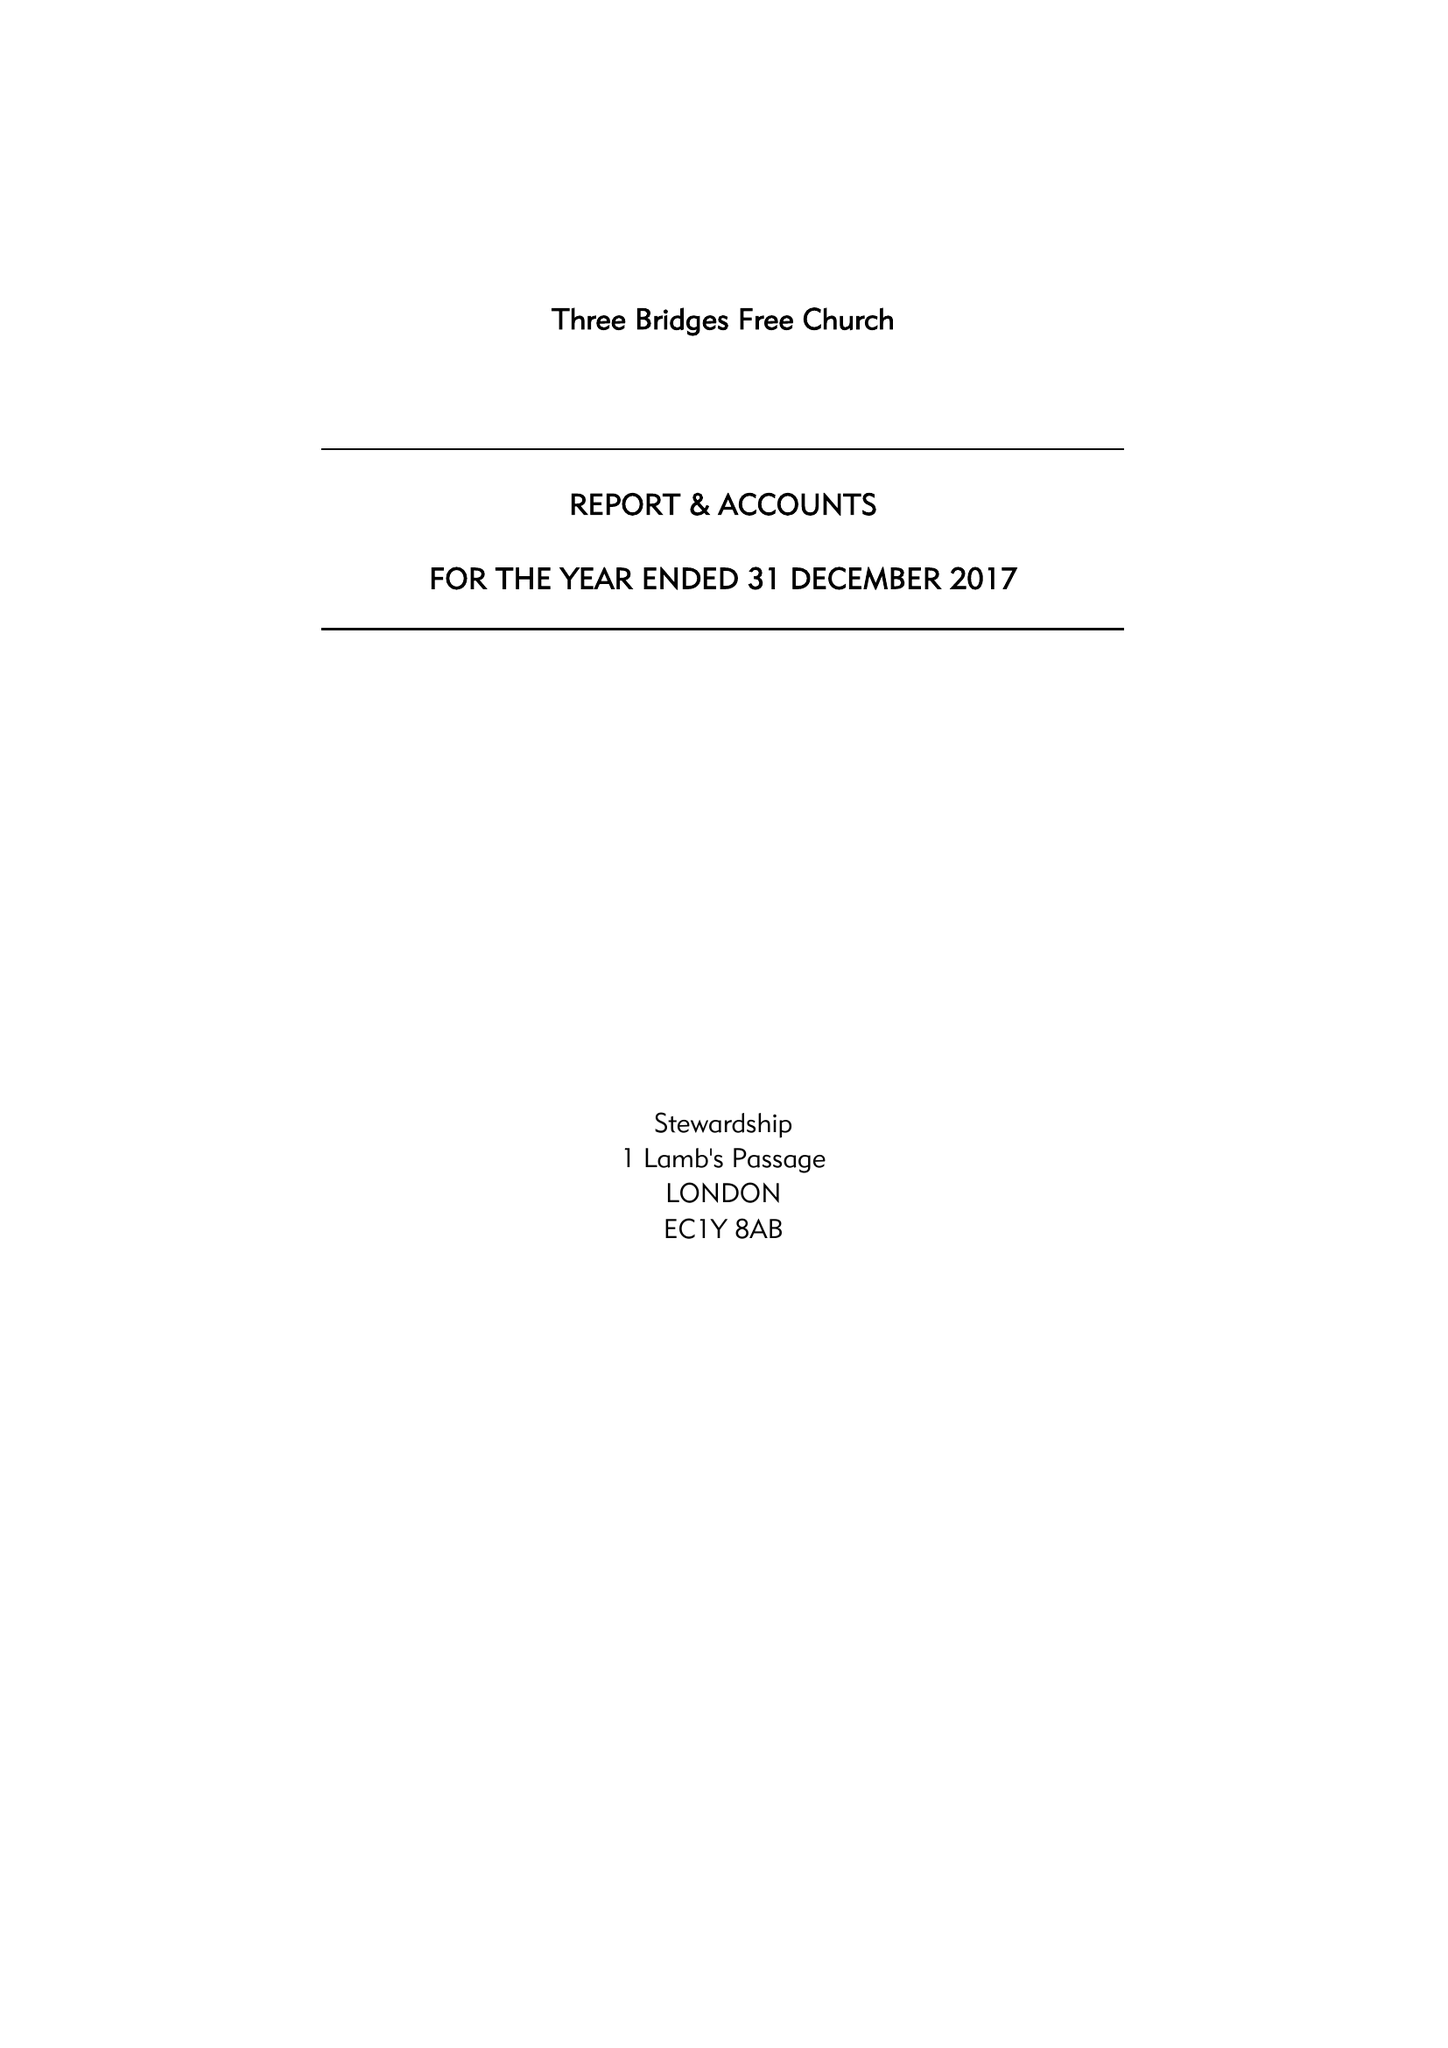What is the value for the address__street_line?
Answer the question using a single word or phrase. THREE BRIDGES ROAD 